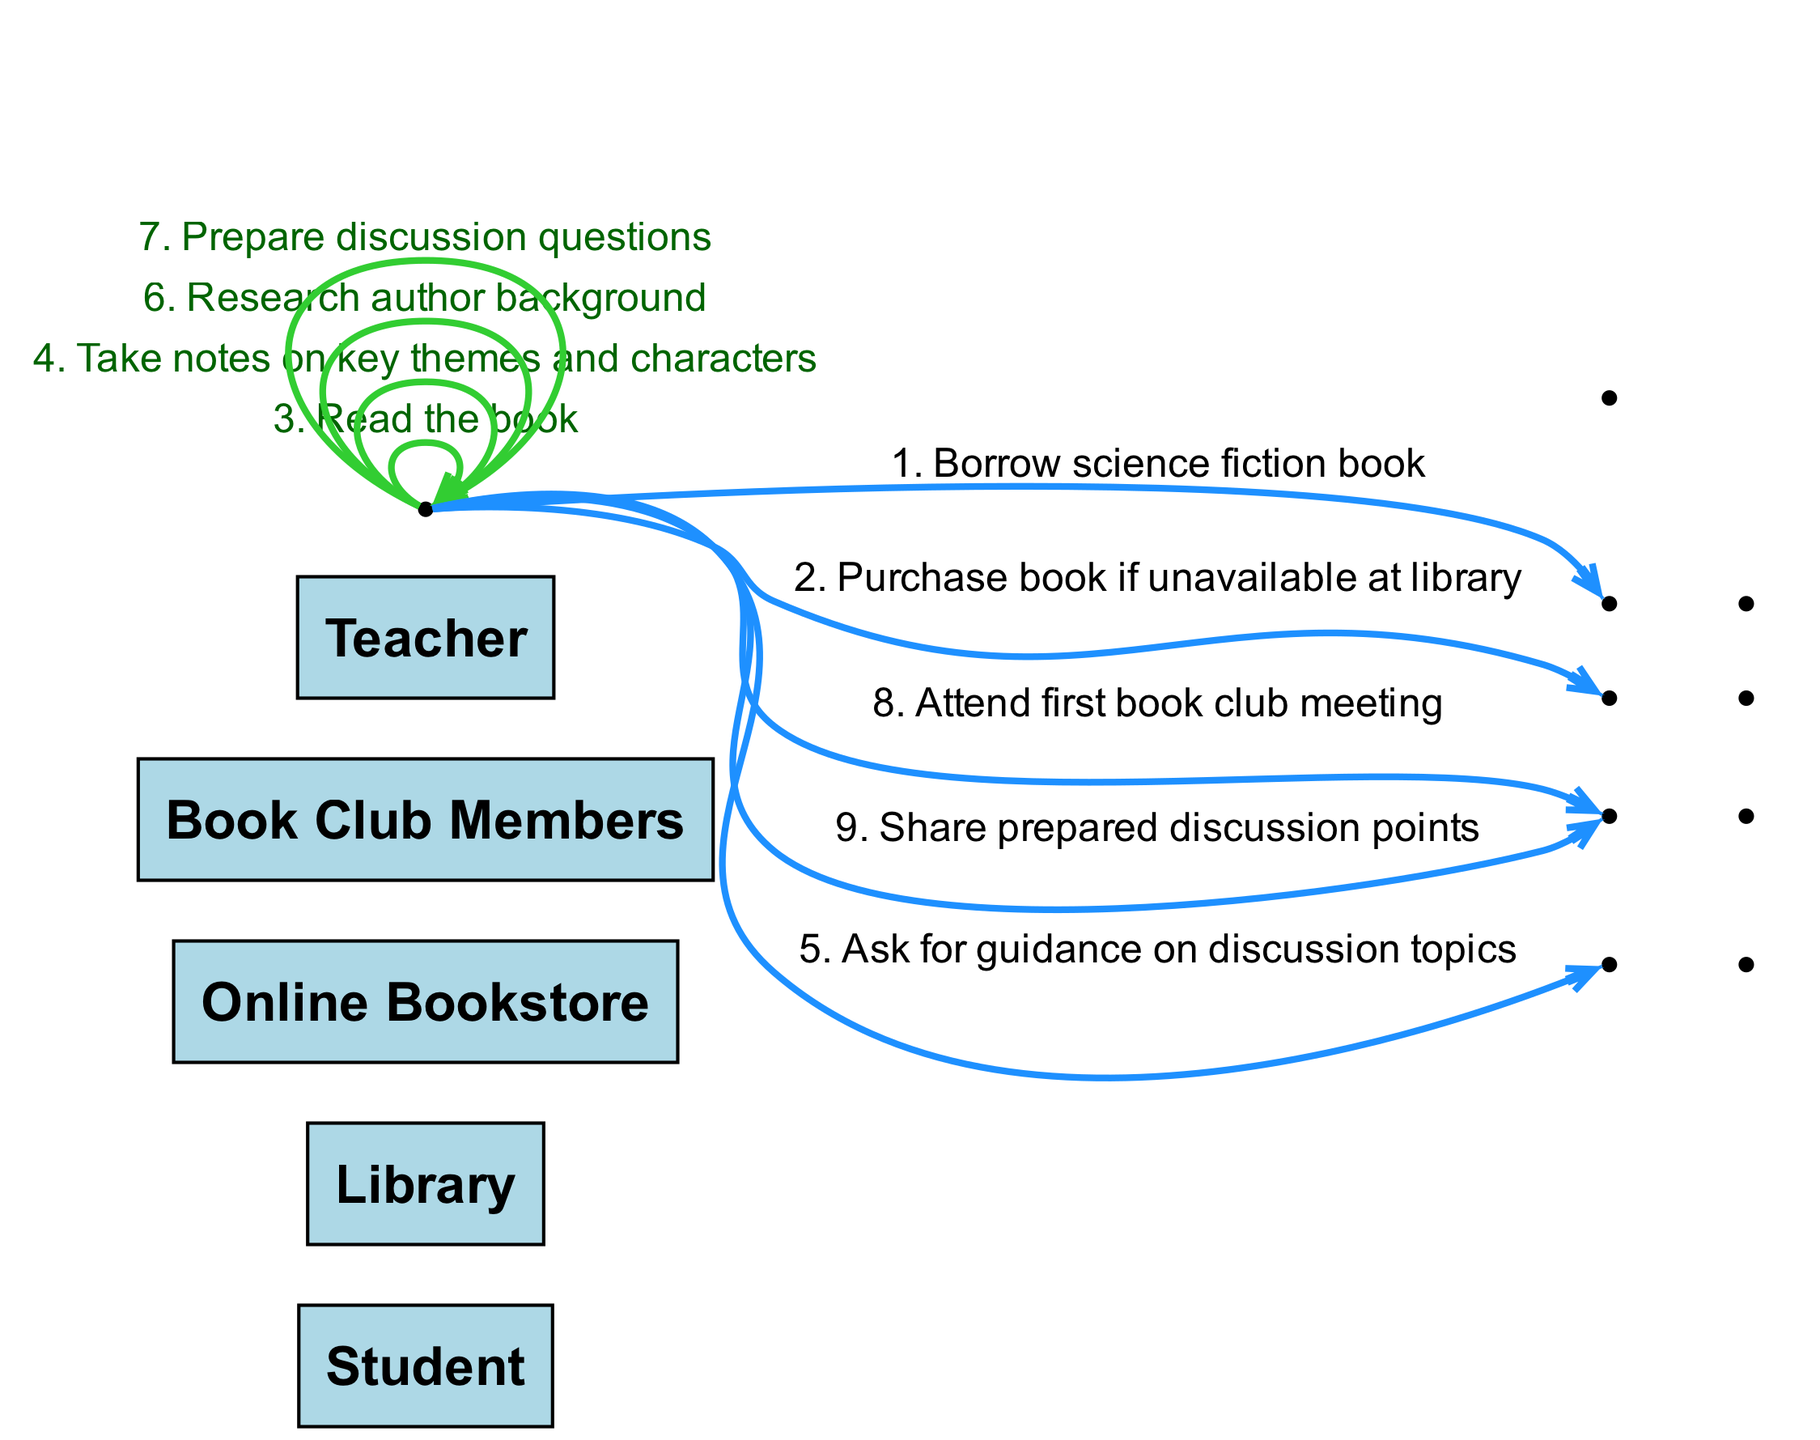What is the first action in the sequence? The first action in the sequence is represented as an edge from the Student to the Library labeled "Borrow science fiction book." It is the initial interaction that starts the research process.
Answer: Borrow science fiction book How many total actors are involved in this diagram? The diagram includes five actors: Student, Library, Online Bookstore, Book Club Members, and Teacher. These are the entities participating in the sequence.
Answer: 5 Which actor does the Student ask for guidance? The Student interacts with the Teacher to ask for guidance on discussion topics, indicated by the edge connecting these two actors.
Answer: Teacher What action is taken if the book is unavailable at the library? If the book is unavailable at the library, the Student will purchase the book from the Online Bookstore, as depicted by the action directed to the Online Bookstore.
Answer: Purchase book if unavailable at library After researching, what does the Student prepare before the book club meeting? Prior to attending the book club meeting, the Student prepares discussion questions, which is one of the actions in the sequence that occurs after taking notes.
Answer: Prepare discussion questions Which action follows the reading of the book? Following the action of the Student reading the book, the next action is taking notes on key themes and characters, establishing the order of processing information.
Answer: Take notes on key themes and characters How many edges are there in total representing actions? Counting all edges in the sequence, there are eight distinct actions represented, showing the flow of interactions between actors.
Answer: 8 What is the last action taken by the Student? The final action in the sequence shows the Student sharing prepared discussion points with Book Club Members, marking the conclusion of the process as they participate in the meeting.
Answer: Share prepared discussion points Which two actions are performed by the Student without interaction with other actors? The two actions performed independently by the Student are "Read the book" and "Take notes on key themes and characters," both actions are within the Student's control.
Answer: Read the book, Take notes on key themes and characters 